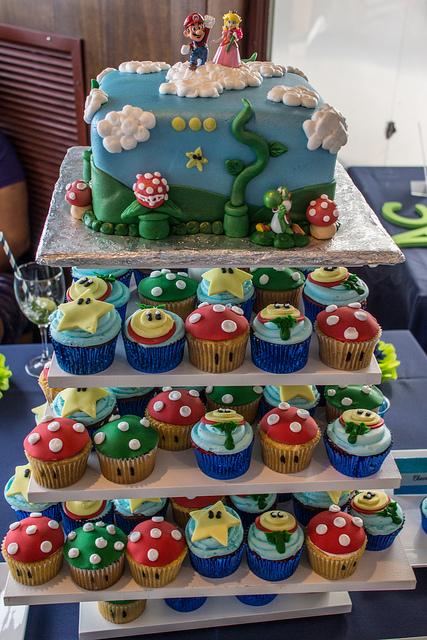How many layers are there?
Quick response, please. 5. Is this for a wedding or a kids birthday party?
Short answer required. Kids birthday party. What video game is the design based on?
Give a very brief answer. Mario. 